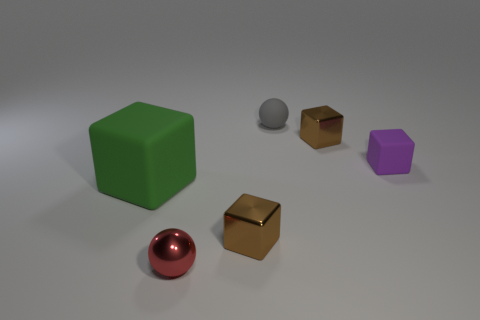Do any of the objects share the same geometry? Yes, there are two pairs of objects sharing the same geometries. The large green cube and the small purple cube both have a cubic shape, and the small silver sphere matches the geometry of the shiny red sphere although they vary in size and color. Are the colors of any objects complementary to each other? The red sphere and green cube's colors are complementary. Red and green are opposite on the color wheel, making them stand out when placed together. 